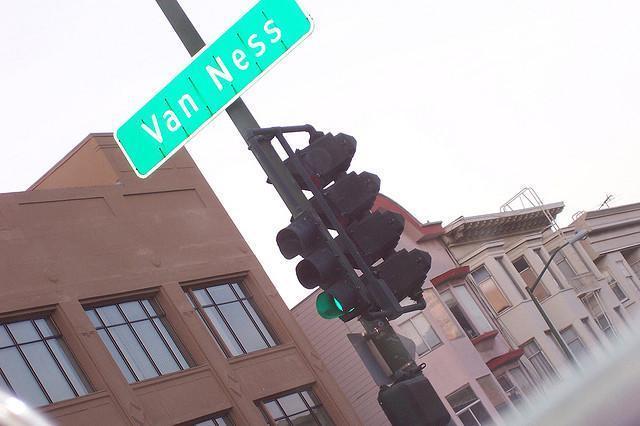How many traffic lights can you see?
Give a very brief answer. 2. How many suitcases are there?
Give a very brief answer. 0. 